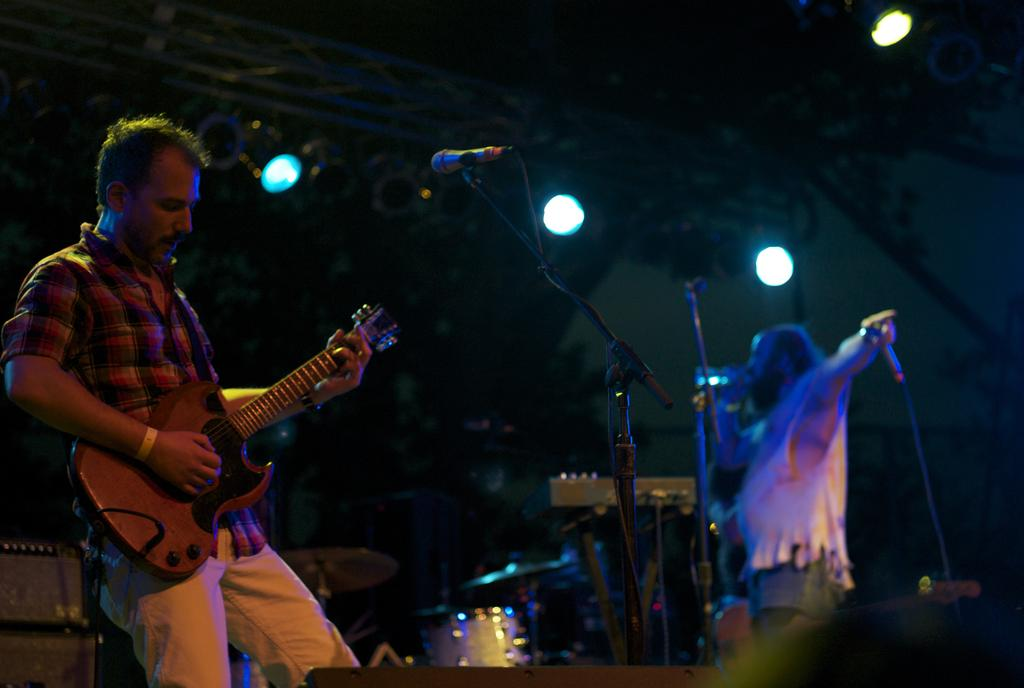How many people are present in the image? There are two people in the image. What are the two people doing in the image? The two people are playing musical instruments. Can you describe the lighting in the image? There are lights visible at the back side of the image. What type of brick is being used as a sound amplifier for the musical instruments in the image? There is no brick present in the image, and the musical instruments do not require a brick for amplification. 